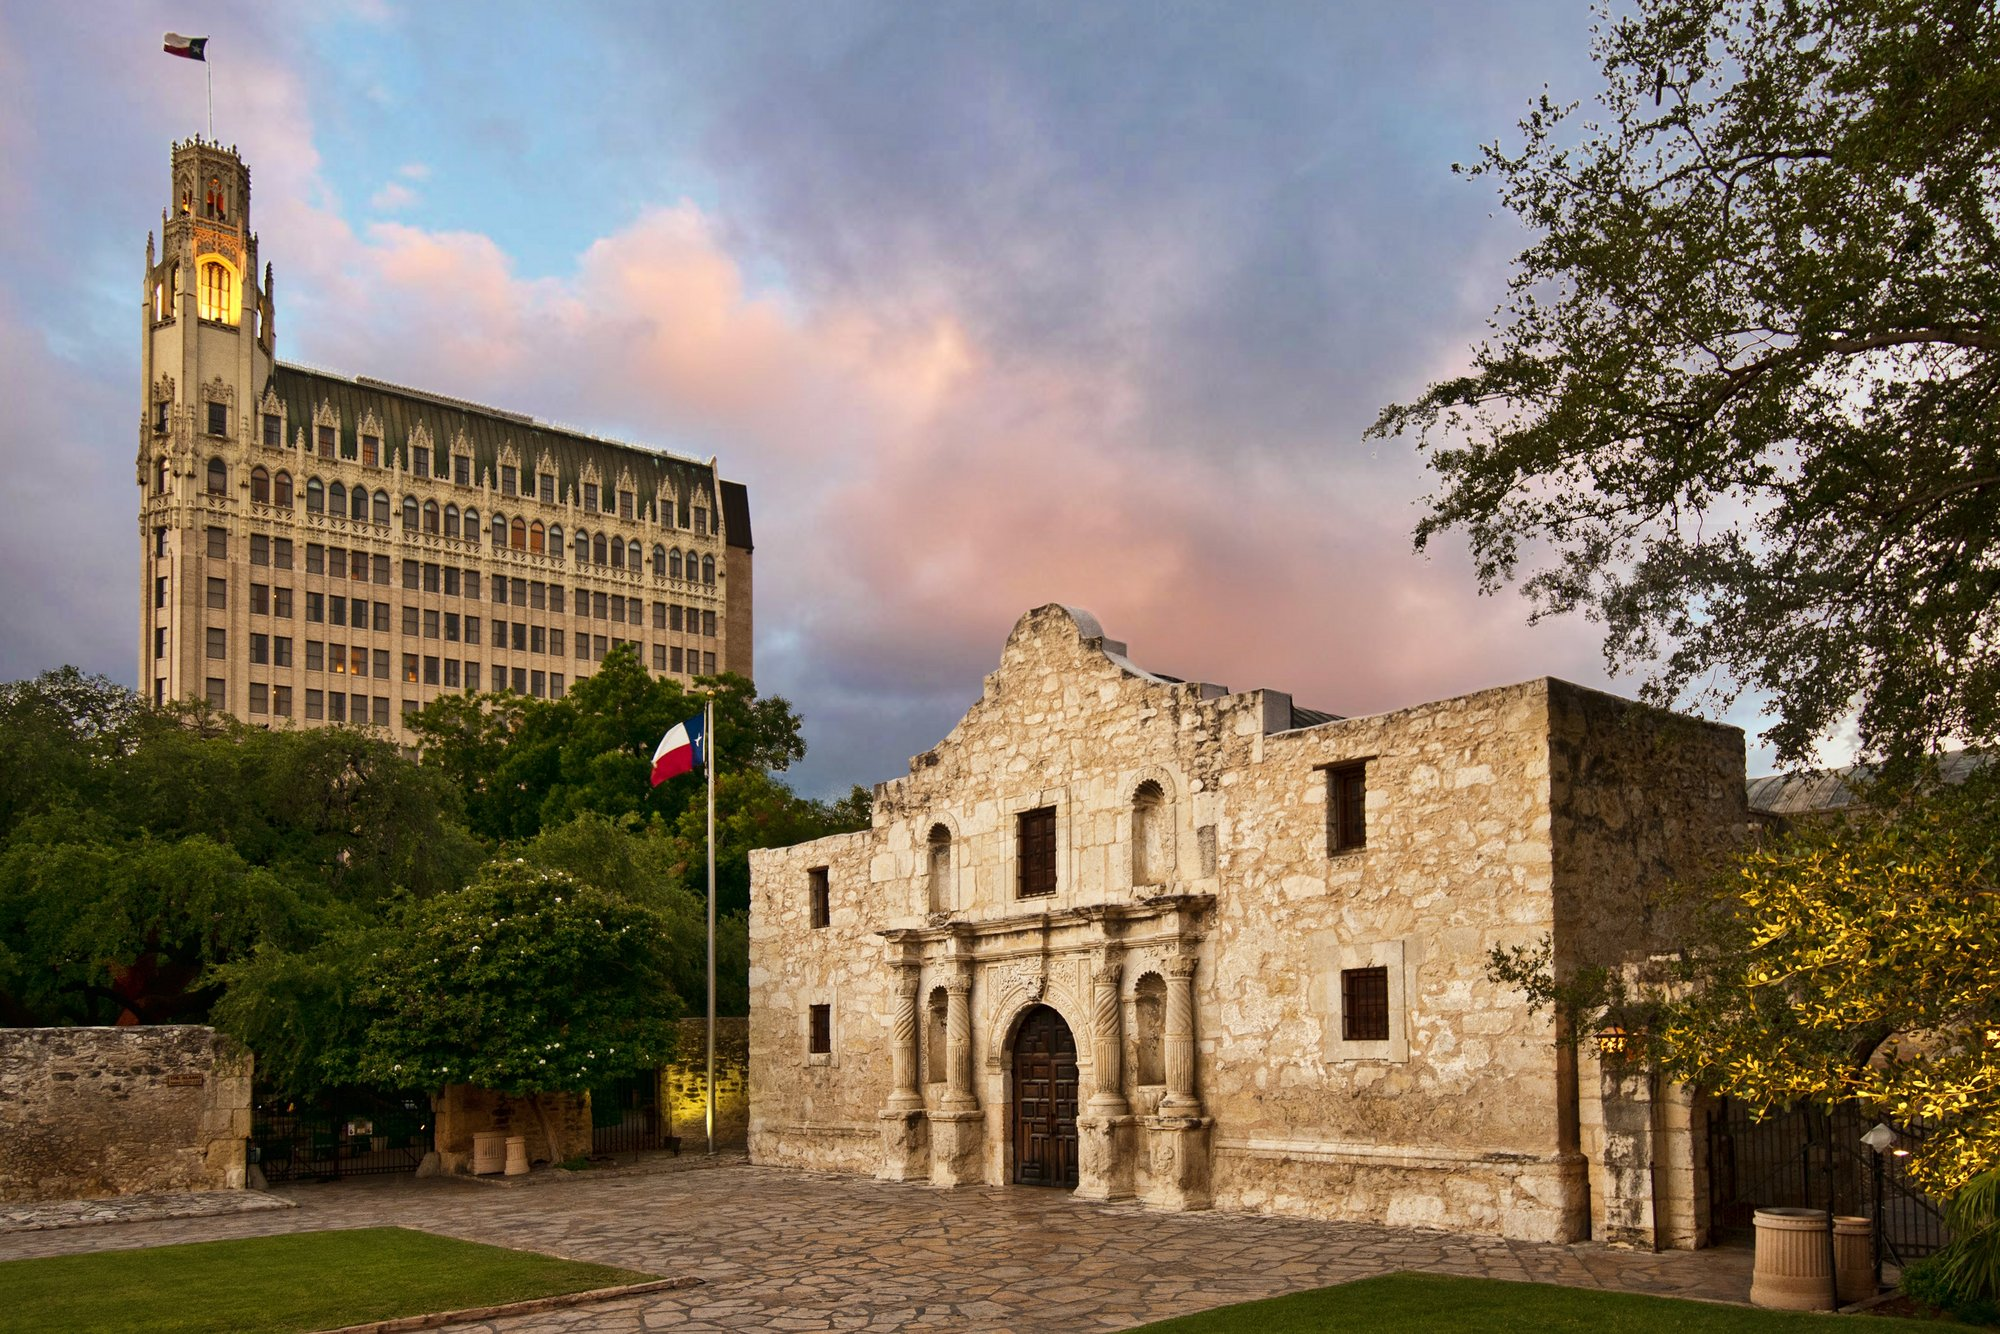Create a poetic description inspired by the image. Beneath a canvas of twilight hues, where history breathes its age-old muse,
Stands the Alamo with strength untold, echoing tales from days of old.
A silent sentinel, stones worn and wise, against the backdrop of modern rise.
The Texas flag flutters with pride, a thousand whispers carried wide.
In the shadow of the clock tower's chime, echoes the brave ones lost to time.
Lush greens weave nature's embrace, around this hallowed, storied place.
Under the pastel skies so grand, the spirits of the past still stand.
As dusk descends with gentle grace, serenity fills this sacred space. 